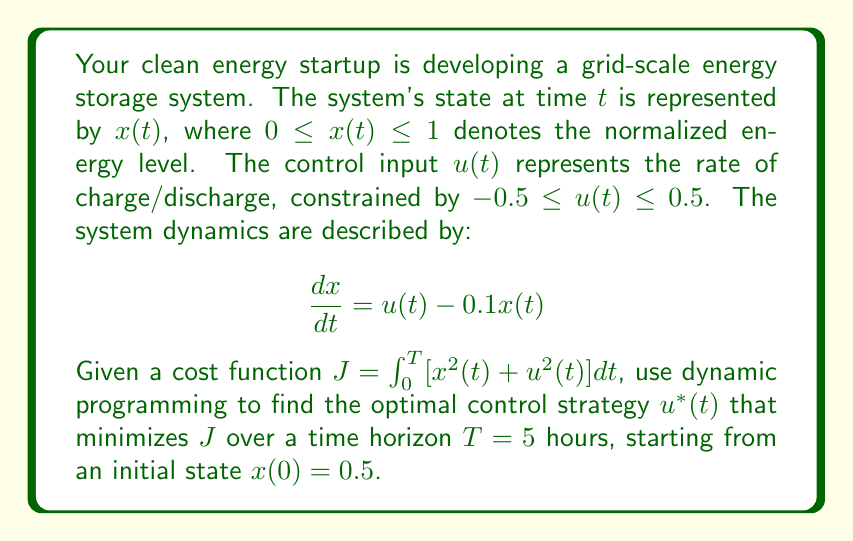What is the answer to this math problem? To solve this problem, we'll use the Hamilton-Jacobi-Bellman (HJB) equation from dynamic programming:

1) Define the value function $V(x,t)$ as the minimum cost-to-go from state $x$ at time $t$:

   $$V(x,t) = \min_{u(\cdot)} \int_t^T [x^2(\tau) + u^2(\tau)] d\tau$$

2) The HJB equation is:

   $$-\frac{\partial V}{\partial t} = \min_u \left[x^2 + u^2 + \frac{\partial V}{\partial x}(u - 0.1x)\right]$$

3) Assume a quadratic form for $V(x,t)$:

   $$V(x,t) = p(t)x^2 + q(t)x + r(t)$$

4) Substitute this into the HJB equation:

   $$-(2p'x^2 + q'x + r') = \min_u [x^2 + u^2 + (2px + q)(u - 0.1x)]$$

5) Minimize the right-hand side with respect to $u$:

   $$\frac{\partial}{\partial u}[u^2 + (2px + q)u] = 0$$
   $$2u + 2px + q = 0$$
   $$u^* = -px - \frac{q}{2}$$

6) Substitute $u^*$ back into the HJB equation:

   $$-(2p'x^2 + q'x + r') = x^2 + (px + \frac{q}{2})^2 + (2px + q)(-px - \frac{q}{2} - 0.1x)$$

7) Equate coefficients of $x^2$, $x$, and constant terms:

   $$-2p' = 1 + p^2 - 2p^2 - 0.2p = 1 - p^2 - 0.2p$$
   $$-q' = pq - pq - 0.1q = -0.1q$$
   $$-r' = \frac{q^2}{4}$$

8) Solve these differential equations with boundary conditions $p(T) = q(T) = r(T) = 0$:

   $$p(t) = \frac{0.1 - \sqrt{1.01}\tanh(\sqrt{1.01}(T-t))}{1 - \tanh(\sqrt{1.01}(T-t))}$$
   $$q(t) = 0$$
   $$r(t) = 0$$

9) The optimal control is therefore:

   $$u^*(t) = -p(t)x(t)$$

10) To find $x(t)$, solve the differential equation:

    $$\frac{dx}{dt} = -p(t)x(t) - 0.1x(t) = -(p(t) + 0.1)x(t)$$

    $$x(t) = x(0)e^{-\int_0^t (p(\tau) + 0.1) d\tau}$$

The optimal control strategy is to charge or discharge at a rate proportional to the current state, with the proportionality constant $-p(t)$ varying over time according to the solution of the Riccati equation.
Answer: $u^*(t) = -p(t)x(t)$, where $p(t) = \frac{0.1 - \sqrt{1.01}\tanh(\sqrt{1.01}(5-t))}{1 - \tanh(\sqrt{1.01}(5-t))}$ 